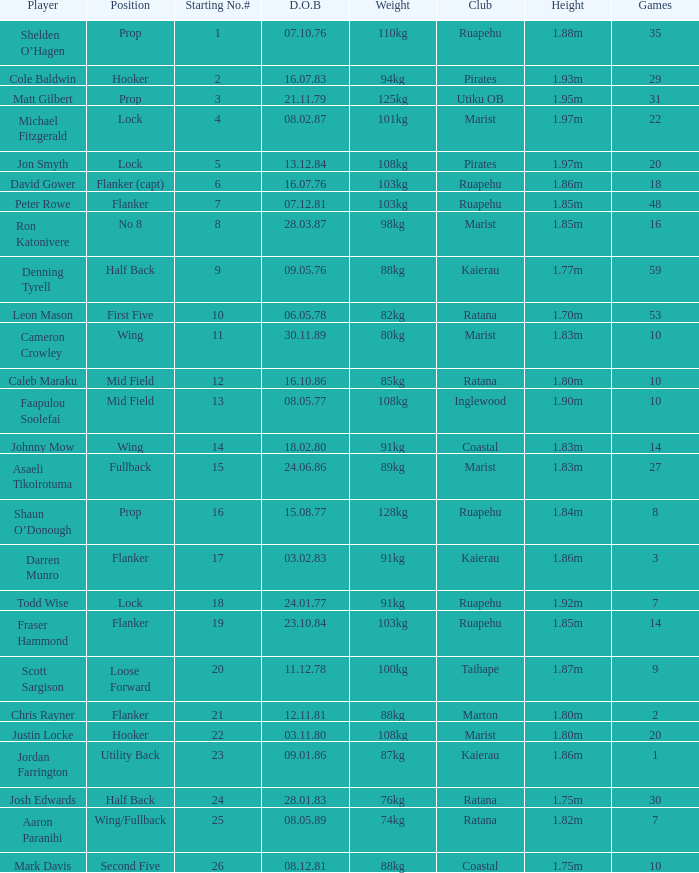What position does the player Todd Wise play in? Lock. 